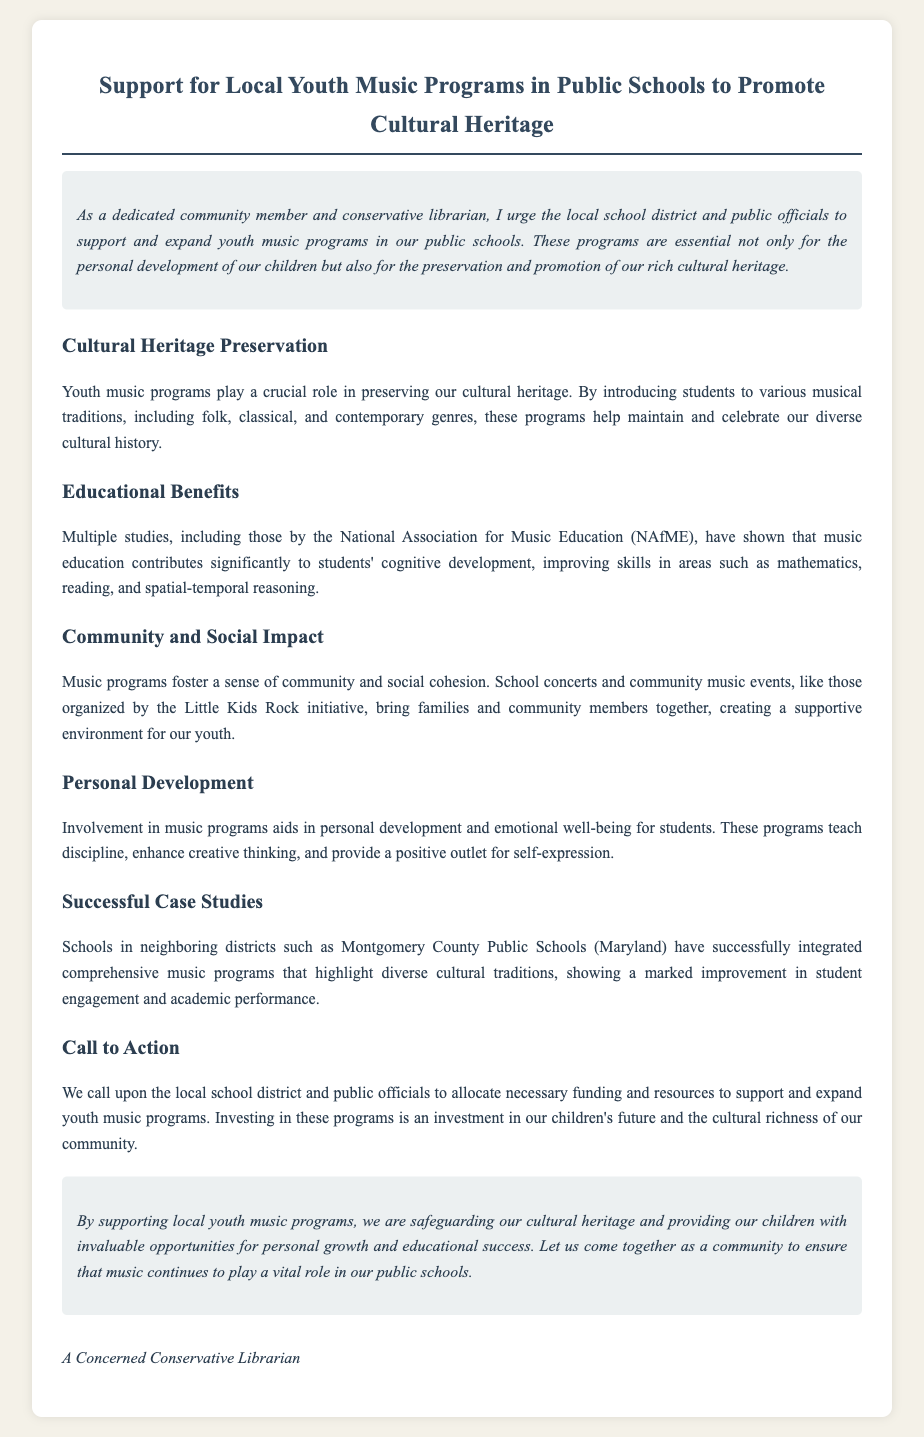What is the title of the petition? The title is mentioned prominently at the top of the document.
Answer: Support for Local Youth Music Programs in Public Schools to Promote Cultural Heritage What is one benefit of youth music programs mentioned in the document? The document outlines several benefits; this is a specific example highlighted under educational benefits.
Answer: Cognitive development Which organization has provided studies cited in the petition? The petition refers to this organization when discussing music education benefits.
Answer: National Association for Music Education (NAfME) What is one example of a successful case study mentioned? The document specifies a neighboring district known for its comprehensive music programs.
Answer: Montgomery County Public Schools (Maryland) What type of programs are being supported in the petition? The focus of the petition is clear from the introduction and throughout the sections.
Answer: Youth music programs Who is calling upon the local school district to support music programs? The identity of the author is stated at the bottom of the document as part of the signature.
Answer: A Concerned Conservative Librarian What is one personal development benefit outlined in the petition? This benefit is specifically stated in the section dedicated to personal development.
Answer: Emotional well-being What is mentioned as a social impact of music programs? The document describes this benefit in the context of community involvement.
Answer: Sense of community 